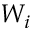Convert formula to latex. <formula><loc_0><loc_0><loc_500><loc_500>W _ { i }</formula> 